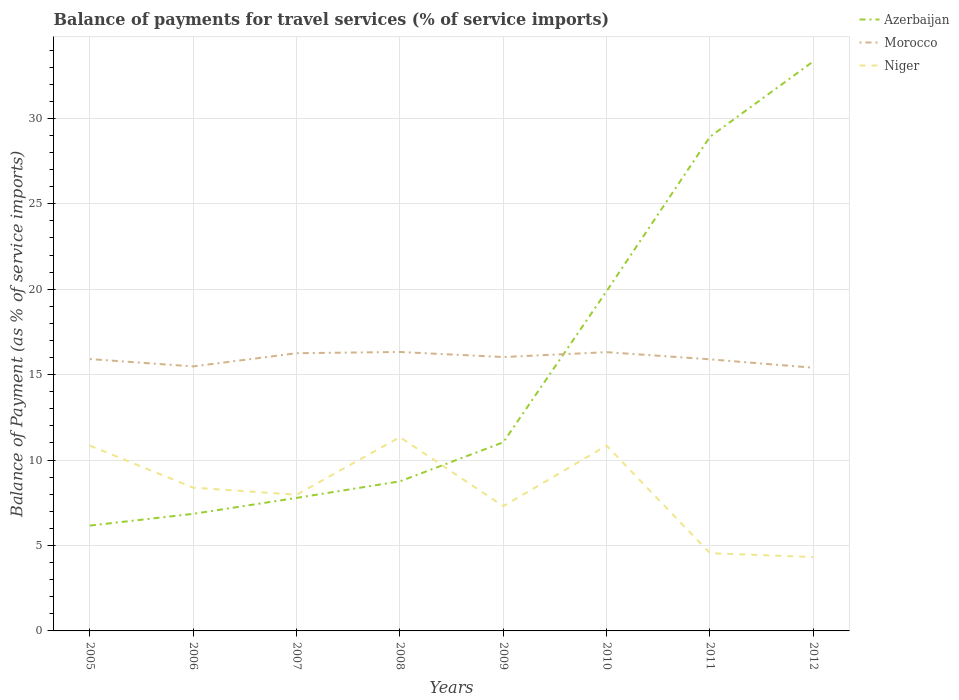How many different coloured lines are there?
Offer a very short reply. 3. Does the line corresponding to Morocco intersect with the line corresponding to Azerbaijan?
Make the answer very short. Yes. Is the number of lines equal to the number of legend labels?
Your response must be concise. Yes. Across all years, what is the maximum balance of payments for travel services in Azerbaijan?
Offer a terse response. 6.17. In which year was the balance of payments for travel services in Morocco maximum?
Your answer should be compact. 2012. What is the total balance of payments for travel services in Niger in the graph?
Offer a very short reply. 6.52. What is the difference between the highest and the second highest balance of payments for travel services in Morocco?
Make the answer very short. 0.92. How many lines are there?
Make the answer very short. 3. Are the values on the major ticks of Y-axis written in scientific E-notation?
Offer a terse response. No. Does the graph contain grids?
Ensure brevity in your answer.  Yes. Where does the legend appear in the graph?
Offer a terse response. Top right. How many legend labels are there?
Ensure brevity in your answer.  3. What is the title of the graph?
Ensure brevity in your answer.  Balance of payments for travel services (% of service imports). What is the label or title of the Y-axis?
Give a very brief answer. Balance of Payment (as % of service imports). What is the Balance of Payment (as % of service imports) in Azerbaijan in 2005?
Make the answer very short. 6.17. What is the Balance of Payment (as % of service imports) of Morocco in 2005?
Your answer should be compact. 15.91. What is the Balance of Payment (as % of service imports) of Niger in 2005?
Offer a terse response. 10.84. What is the Balance of Payment (as % of service imports) in Azerbaijan in 2006?
Ensure brevity in your answer.  6.85. What is the Balance of Payment (as % of service imports) in Morocco in 2006?
Make the answer very short. 15.48. What is the Balance of Payment (as % of service imports) of Niger in 2006?
Offer a terse response. 8.39. What is the Balance of Payment (as % of service imports) of Azerbaijan in 2007?
Your response must be concise. 7.79. What is the Balance of Payment (as % of service imports) of Morocco in 2007?
Your response must be concise. 16.25. What is the Balance of Payment (as % of service imports) of Niger in 2007?
Offer a terse response. 7.97. What is the Balance of Payment (as % of service imports) in Azerbaijan in 2008?
Ensure brevity in your answer.  8.75. What is the Balance of Payment (as % of service imports) in Morocco in 2008?
Ensure brevity in your answer.  16.33. What is the Balance of Payment (as % of service imports) in Niger in 2008?
Your answer should be very brief. 11.34. What is the Balance of Payment (as % of service imports) in Azerbaijan in 2009?
Your response must be concise. 11.04. What is the Balance of Payment (as % of service imports) in Morocco in 2009?
Offer a very short reply. 16.03. What is the Balance of Payment (as % of service imports) of Niger in 2009?
Offer a very short reply. 7.3. What is the Balance of Payment (as % of service imports) in Azerbaijan in 2010?
Offer a very short reply. 19.89. What is the Balance of Payment (as % of service imports) in Morocco in 2010?
Keep it short and to the point. 16.32. What is the Balance of Payment (as % of service imports) of Niger in 2010?
Your answer should be compact. 10.85. What is the Balance of Payment (as % of service imports) in Azerbaijan in 2011?
Your answer should be very brief. 28.92. What is the Balance of Payment (as % of service imports) in Morocco in 2011?
Your answer should be very brief. 15.9. What is the Balance of Payment (as % of service imports) in Niger in 2011?
Your answer should be very brief. 4.55. What is the Balance of Payment (as % of service imports) of Azerbaijan in 2012?
Provide a short and direct response. 33.34. What is the Balance of Payment (as % of service imports) in Morocco in 2012?
Make the answer very short. 15.41. What is the Balance of Payment (as % of service imports) in Niger in 2012?
Ensure brevity in your answer.  4.32. Across all years, what is the maximum Balance of Payment (as % of service imports) of Azerbaijan?
Offer a terse response. 33.34. Across all years, what is the maximum Balance of Payment (as % of service imports) in Morocco?
Make the answer very short. 16.33. Across all years, what is the maximum Balance of Payment (as % of service imports) of Niger?
Your answer should be very brief. 11.34. Across all years, what is the minimum Balance of Payment (as % of service imports) of Azerbaijan?
Provide a short and direct response. 6.17. Across all years, what is the minimum Balance of Payment (as % of service imports) in Morocco?
Provide a succinct answer. 15.41. Across all years, what is the minimum Balance of Payment (as % of service imports) in Niger?
Provide a succinct answer. 4.32. What is the total Balance of Payment (as % of service imports) in Azerbaijan in the graph?
Provide a short and direct response. 122.75. What is the total Balance of Payment (as % of service imports) of Morocco in the graph?
Your response must be concise. 127.63. What is the total Balance of Payment (as % of service imports) of Niger in the graph?
Provide a short and direct response. 65.56. What is the difference between the Balance of Payment (as % of service imports) in Azerbaijan in 2005 and that in 2006?
Your answer should be compact. -0.69. What is the difference between the Balance of Payment (as % of service imports) in Morocco in 2005 and that in 2006?
Offer a terse response. 0.43. What is the difference between the Balance of Payment (as % of service imports) of Niger in 2005 and that in 2006?
Your response must be concise. 2.46. What is the difference between the Balance of Payment (as % of service imports) of Azerbaijan in 2005 and that in 2007?
Offer a terse response. -1.62. What is the difference between the Balance of Payment (as % of service imports) in Morocco in 2005 and that in 2007?
Make the answer very short. -0.34. What is the difference between the Balance of Payment (as % of service imports) of Niger in 2005 and that in 2007?
Provide a succinct answer. 2.87. What is the difference between the Balance of Payment (as % of service imports) of Azerbaijan in 2005 and that in 2008?
Give a very brief answer. -2.59. What is the difference between the Balance of Payment (as % of service imports) of Morocco in 2005 and that in 2008?
Provide a short and direct response. -0.42. What is the difference between the Balance of Payment (as % of service imports) of Niger in 2005 and that in 2008?
Provide a succinct answer. -0.5. What is the difference between the Balance of Payment (as % of service imports) of Azerbaijan in 2005 and that in 2009?
Ensure brevity in your answer.  -4.87. What is the difference between the Balance of Payment (as % of service imports) in Morocco in 2005 and that in 2009?
Your answer should be very brief. -0.12. What is the difference between the Balance of Payment (as % of service imports) in Niger in 2005 and that in 2009?
Make the answer very short. 3.54. What is the difference between the Balance of Payment (as % of service imports) of Azerbaijan in 2005 and that in 2010?
Your answer should be very brief. -13.72. What is the difference between the Balance of Payment (as % of service imports) in Morocco in 2005 and that in 2010?
Provide a succinct answer. -0.41. What is the difference between the Balance of Payment (as % of service imports) of Niger in 2005 and that in 2010?
Your answer should be very brief. -0. What is the difference between the Balance of Payment (as % of service imports) of Azerbaijan in 2005 and that in 2011?
Make the answer very short. -22.76. What is the difference between the Balance of Payment (as % of service imports) in Morocco in 2005 and that in 2011?
Ensure brevity in your answer.  0.01. What is the difference between the Balance of Payment (as % of service imports) in Niger in 2005 and that in 2011?
Offer a very short reply. 6.29. What is the difference between the Balance of Payment (as % of service imports) in Azerbaijan in 2005 and that in 2012?
Make the answer very short. -27.17. What is the difference between the Balance of Payment (as % of service imports) in Morocco in 2005 and that in 2012?
Keep it short and to the point. 0.51. What is the difference between the Balance of Payment (as % of service imports) of Niger in 2005 and that in 2012?
Your answer should be very brief. 6.52. What is the difference between the Balance of Payment (as % of service imports) of Azerbaijan in 2006 and that in 2007?
Keep it short and to the point. -0.93. What is the difference between the Balance of Payment (as % of service imports) in Morocco in 2006 and that in 2007?
Provide a succinct answer. -0.77. What is the difference between the Balance of Payment (as % of service imports) of Niger in 2006 and that in 2007?
Provide a succinct answer. 0.41. What is the difference between the Balance of Payment (as % of service imports) of Azerbaijan in 2006 and that in 2008?
Offer a terse response. -1.9. What is the difference between the Balance of Payment (as % of service imports) in Morocco in 2006 and that in 2008?
Your answer should be very brief. -0.84. What is the difference between the Balance of Payment (as % of service imports) in Niger in 2006 and that in 2008?
Ensure brevity in your answer.  -2.96. What is the difference between the Balance of Payment (as % of service imports) of Azerbaijan in 2006 and that in 2009?
Offer a very short reply. -4.19. What is the difference between the Balance of Payment (as % of service imports) of Morocco in 2006 and that in 2009?
Offer a terse response. -0.55. What is the difference between the Balance of Payment (as % of service imports) of Niger in 2006 and that in 2009?
Provide a succinct answer. 1.09. What is the difference between the Balance of Payment (as % of service imports) of Azerbaijan in 2006 and that in 2010?
Make the answer very short. -13.04. What is the difference between the Balance of Payment (as % of service imports) in Morocco in 2006 and that in 2010?
Provide a short and direct response. -0.83. What is the difference between the Balance of Payment (as % of service imports) of Niger in 2006 and that in 2010?
Your answer should be compact. -2.46. What is the difference between the Balance of Payment (as % of service imports) in Azerbaijan in 2006 and that in 2011?
Offer a very short reply. -22.07. What is the difference between the Balance of Payment (as % of service imports) of Morocco in 2006 and that in 2011?
Make the answer very short. -0.41. What is the difference between the Balance of Payment (as % of service imports) of Niger in 2006 and that in 2011?
Provide a short and direct response. 3.84. What is the difference between the Balance of Payment (as % of service imports) in Azerbaijan in 2006 and that in 2012?
Provide a succinct answer. -26.49. What is the difference between the Balance of Payment (as % of service imports) of Morocco in 2006 and that in 2012?
Ensure brevity in your answer.  0.08. What is the difference between the Balance of Payment (as % of service imports) of Niger in 2006 and that in 2012?
Provide a short and direct response. 4.06. What is the difference between the Balance of Payment (as % of service imports) in Azerbaijan in 2007 and that in 2008?
Your answer should be very brief. -0.97. What is the difference between the Balance of Payment (as % of service imports) in Morocco in 2007 and that in 2008?
Offer a terse response. -0.07. What is the difference between the Balance of Payment (as % of service imports) of Niger in 2007 and that in 2008?
Your answer should be very brief. -3.37. What is the difference between the Balance of Payment (as % of service imports) of Azerbaijan in 2007 and that in 2009?
Your response must be concise. -3.26. What is the difference between the Balance of Payment (as % of service imports) of Morocco in 2007 and that in 2009?
Offer a very short reply. 0.22. What is the difference between the Balance of Payment (as % of service imports) in Niger in 2007 and that in 2009?
Give a very brief answer. 0.67. What is the difference between the Balance of Payment (as % of service imports) in Azerbaijan in 2007 and that in 2010?
Offer a terse response. -12.1. What is the difference between the Balance of Payment (as % of service imports) of Morocco in 2007 and that in 2010?
Offer a very short reply. -0.06. What is the difference between the Balance of Payment (as % of service imports) of Niger in 2007 and that in 2010?
Offer a terse response. -2.87. What is the difference between the Balance of Payment (as % of service imports) of Azerbaijan in 2007 and that in 2011?
Give a very brief answer. -21.14. What is the difference between the Balance of Payment (as % of service imports) in Morocco in 2007 and that in 2011?
Offer a terse response. 0.36. What is the difference between the Balance of Payment (as % of service imports) in Niger in 2007 and that in 2011?
Keep it short and to the point. 3.42. What is the difference between the Balance of Payment (as % of service imports) of Azerbaijan in 2007 and that in 2012?
Offer a very short reply. -25.55. What is the difference between the Balance of Payment (as % of service imports) of Morocco in 2007 and that in 2012?
Your response must be concise. 0.85. What is the difference between the Balance of Payment (as % of service imports) of Niger in 2007 and that in 2012?
Ensure brevity in your answer.  3.65. What is the difference between the Balance of Payment (as % of service imports) in Azerbaijan in 2008 and that in 2009?
Offer a very short reply. -2.29. What is the difference between the Balance of Payment (as % of service imports) in Morocco in 2008 and that in 2009?
Offer a terse response. 0.3. What is the difference between the Balance of Payment (as % of service imports) in Niger in 2008 and that in 2009?
Offer a very short reply. 4.04. What is the difference between the Balance of Payment (as % of service imports) in Azerbaijan in 2008 and that in 2010?
Make the answer very short. -11.13. What is the difference between the Balance of Payment (as % of service imports) of Morocco in 2008 and that in 2010?
Give a very brief answer. 0.01. What is the difference between the Balance of Payment (as % of service imports) of Niger in 2008 and that in 2010?
Your answer should be compact. 0.5. What is the difference between the Balance of Payment (as % of service imports) in Azerbaijan in 2008 and that in 2011?
Offer a very short reply. -20.17. What is the difference between the Balance of Payment (as % of service imports) of Morocco in 2008 and that in 2011?
Provide a short and direct response. 0.43. What is the difference between the Balance of Payment (as % of service imports) of Niger in 2008 and that in 2011?
Your answer should be very brief. 6.79. What is the difference between the Balance of Payment (as % of service imports) of Azerbaijan in 2008 and that in 2012?
Your response must be concise. -24.58. What is the difference between the Balance of Payment (as % of service imports) of Morocco in 2008 and that in 2012?
Your response must be concise. 0.92. What is the difference between the Balance of Payment (as % of service imports) of Niger in 2008 and that in 2012?
Ensure brevity in your answer.  7.02. What is the difference between the Balance of Payment (as % of service imports) in Azerbaijan in 2009 and that in 2010?
Offer a terse response. -8.85. What is the difference between the Balance of Payment (as % of service imports) in Morocco in 2009 and that in 2010?
Provide a succinct answer. -0.29. What is the difference between the Balance of Payment (as % of service imports) in Niger in 2009 and that in 2010?
Offer a terse response. -3.55. What is the difference between the Balance of Payment (as % of service imports) of Azerbaijan in 2009 and that in 2011?
Provide a short and direct response. -17.88. What is the difference between the Balance of Payment (as % of service imports) of Morocco in 2009 and that in 2011?
Provide a short and direct response. 0.13. What is the difference between the Balance of Payment (as % of service imports) of Niger in 2009 and that in 2011?
Make the answer very short. 2.75. What is the difference between the Balance of Payment (as % of service imports) of Azerbaijan in 2009 and that in 2012?
Offer a terse response. -22.3. What is the difference between the Balance of Payment (as % of service imports) in Morocco in 2009 and that in 2012?
Ensure brevity in your answer.  0.62. What is the difference between the Balance of Payment (as % of service imports) of Niger in 2009 and that in 2012?
Offer a terse response. 2.98. What is the difference between the Balance of Payment (as % of service imports) in Azerbaijan in 2010 and that in 2011?
Give a very brief answer. -9.04. What is the difference between the Balance of Payment (as % of service imports) of Morocco in 2010 and that in 2011?
Provide a short and direct response. 0.42. What is the difference between the Balance of Payment (as % of service imports) in Niger in 2010 and that in 2011?
Your response must be concise. 6.29. What is the difference between the Balance of Payment (as % of service imports) of Azerbaijan in 2010 and that in 2012?
Make the answer very short. -13.45. What is the difference between the Balance of Payment (as % of service imports) of Morocco in 2010 and that in 2012?
Ensure brevity in your answer.  0.91. What is the difference between the Balance of Payment (as % of service imports) of Niger in 2010 and that in 2012?
Your answer should be compact. 6.52. What is the difference between the Balance of Payment (as % of service imports) of Azerbaijan in 2011 and that in 2012?
Make the answer very short. -4.41. What is the difference between the Balance of Payment (as % of service imports) of Morocco in 2011 and that in 2012?
Your answer should be compact. 0.49. What is the difference between the Balance of Payment (as % of service imports) of Niger in 2011 and that in 2012?
Make the answer very short. 0.23. What is the difference between the Balance of Payment (as % of service imports) in Azerbaijan in 2005 and the Balance of Payment (as % of service imports) in Morocco in 2006?
Ensure brevity in your answer.  -9.32. What is the difference between the Balance of Payment (as % of service imports) of Azerbaijan in 2005 and the Balance of Payment (as % of service imports) of Niger in 2006?
Make the answer very short. -2.22. What is the difference between the Balance of Payment (as % of service imports) in Morocco in 2005 and the Balance of Payment (as % of service imports) in Niger in 2006?
Make the answer very short. 7.53. What is the difference between the Balance of Payment (as % of service imports) of Azerbaijan in 2005 and the Balance of Payment (as % of service imports) of Morocco in 2007?
Provide a succinct answer. -10.09. What is the difference between the Balance of Payment (as % of service imports) in Azerbaijan in 2005 and the Balance of Payment (as % of service imports) in Niger in 2007?
Keep it short and to the point. -1.81. What is the difference between the Balance of Payment (as % of service imports) of Morocco in 2005 and the Balance of Payment (as % of service imports) of Niger in 2007?
Offer a terse response. 7.94. What is the difference between the Balance of Payment (as % of service imports) in Azerbaijan in 2005 and the Balance of Payment (as % of service imports) in Morocco in 2008?
Keep it short and to the point. -10.16. What is the difference between the Balance of Payment (as % of service imports) of Azerbaijan in 2005 and the Balance of Payment (as % of service imports) of Niger in 2008?
Offer a terse response. -5.17. What is the difference between the Balance of Payment (as % of service imports) in Morocco in 2005 and the Balance of Payment (as % of service imports) in Niger in 2008?
Offer a very short reply. 4.57. What is the difference between the Balance of Payment (as % of service imports) of Azerbaijan in 2005 and the Balance of Payment (as % of service imports) of Morocco in 2009?
Keep it short and to the point. -9.86. What is the difference between the Balance of Payment (as % of service imports) in Azerbaijan in 2005 and the Balance of Payment (as % of service imports) in Niger in 2009?
Offer a terse response. -1.13. What is the difference between the Balance of Payment (as % of service imports) in Morocco in 2005 and the Balance of Payment (as % of service imports) in Niger in 2009?
Offer a very short reply. 8.61. What is the difference between the Balance of Payment (as % of service imports) in Azerbaijan in 2005 and the Balance of Payment (as % of service imports) in Morocco in 2010?
Offer a terse response. -10.15. What is the difference between the Balance of Payment (as % of service imports) in Azerbaijan in 2005 and the Balance of Payment (as % of service imports) in Niger in 2010?
Provide a short and direct response. -4.68. What is the difference between the Balance of Payment (as % of service imports) of Morocco in 2005 and the Balance of Payment (as % of service imports) of Niger in 2010?
Offer a terse response. 5.07. What is the difference between the Balance of Payment (as % of service imports) in Azerbaijan in 2005 and the Balance of Payment (as % of service imports) in Morocco in 2011?
Give a very brief answer. -9.73. What is the difference between the Balance of Payment (as % of service imports) of Azerbaijan in 2005 and the Balance of Payment (as % of service imports) of Niger in 2011?
Offer a terse response. 1.62. What is the difference between the Balance of Payment (as % of service imports) of Morocco in 2005 and the Balance of Payment (as % of service imports) of Niger in 2011?
Give a very brief answer. 11.36. What is the difference between the Balance of Payment (as % of service imports) of Azerbaijan in 2005 and the Balance of Payment (as % of service imports) of Morocco in 2012?
Provide a short and direct response. -9.24. What is the difference between the Balance of Payment (as % of service imports) of Azerbaijan in 2005 and the Balance of Payment (as % of service imports) of Niger in 2012?
Ensure brevity in your answer.  1.85. What is the difference between the Balance of Payment (as % of service imports) of Morocco in 2005 and the Balance of Payment (as % of service imports) of Niger in 2012?
Provide a short and direct response. 11.59. What is the difference between the Balance of Payment (as % of service imports) of Azerbaijan in 2006 and the Balance of Payment (as % of service imports) of Morocco in 2007?
Give a very brief answer. -9.4. What is the difference between the Balance of Payment (as % of service imports) of Azerbaijan in 2006 and the Balance of Payment (as % of service imports) of Niger in 2007?
Offer a very short reply. -1.12. What is the difference between the Balance of Payment (as % of service imports) of Morocco in 2006 and the Balance of Payment (as % of service imports) of Niger in 2007?
Make the answer very short. 7.51. What is the difference between the Balance of Payment (as % of service imports) in Azerbaijan in 2006 and the Balance of Payment (as % of service imports) in Morocco in 2008?
Your response must be concise. -9.48. What is the difference between the Balance of Payment (as % of service imports) of Azerbaijan in 2006 and the Balance of Payment (as % of service imports) of Niger in 2008?
Offer a very short reply. -4.49. What is the difference between the Balance of Payment (as % of service imports) in Morocco in 2006 and the Balance of Payment (as % of service imports) in Niger in 2008?
Provide a short and direct response. 4.14. What is the difference between the Balance of Payment (as % of service imports) of Azerbaijan in 2006 and the Balance of Payment (as % of service imports) of Morocco in 2009?
Offer a terse response. -9.18. What is the difference between the Balance of Payment (as % of service imports) of Azerbaijan in 2006 and the Balance of Payment (as % of service imports) of Niger in 2009?
Offer a very short reply. -0.45. What is the difference between the Balance of Payment (as % of service imports) of Morocco in 2006 and the Balance of Payment (as % of service imports) of Niger in 2009?
Your answer should be very brief. 8.18. What is the difference between the Balance of Payment (as % of service imports) in Azerbaijan in 2006 and the Balance of Payment (as % of service imports) in Morocco in 2010?
Provide a short and direct response. -9.47. What is the difference between the Balance of Payment (as % of service imports) in Azerbaijan in 2006 and the Balance of Payment (as % of service imports) in Niger in 2010?
Offer a very short reply. -3.99. What is the difference between the Balance of Payment (as % of service imports) in Morocco in 2006 and the Balance of Payment (as % of service imports) in Niger in 2010?
Ensure brevity in your answer.  4.64. What is the difference between the Balance of Payment (as % of service imports) of Azerbaijan in 2006 and the Balance of Payment (as % of service imports) of Morocco in 2011?
Keep it short and to the point. -9.04. What is the difference between the Balance of Payment (as % of service imports) in Azerbaijan in 2006 and the Balance of Payment (as % of service imports) in Niger in 2011?
Offer a very short reply. 2.3. What is the difference between the Balance of Payment (as % of service imports) in Morocco in 2006 and the Balance of Payment (as % of service imports) in Niger in 2011?
Keep it short and to the point. 10.93. What is the difference between the Balance of Payment (as % of service imports) of Azerbaijan in 2006 and the Balance of Payment (as % of service imports) of Morocco in 2012?
Your response must be concise. -8.55. What is the difference between the Balance of Payment (as % of service imports) in Azerbaijan in 2006 and the Balance of Payment (as % of service imports) in Niger in 2012?
Make the answer very short. 2.53. What is the difference between the Balance of Payment (as % of service imports) in Morocco in 2006 and the Balance of Payment (as % of service imports) in Niger in 2012?
Your answer should be compact. 11.16. What is the difference between the Balance of Payment (as % of service imports) of Azerbaijan in 2007 and the Balance of Payment (as % of service imports) of Morocco in 2008?
Make the answer very short. -8.54. What is the difference between the Balance of Payment (as % of service imports) in Azerbaijan in 2007 and the Balance of Payment (as % of service imports) in Niger in 2008?
Provide a short and direct response. -3.56. What is the difference between the Balance of Payment (as % of service imports) in Morocco in 2007 and the Balance of Payment (as % of service imports) in Niger in 2008?
Provide a short and direct response. 4.91. What is the difference between the Balance of Payment (as % of service imports) in Azerbaijan in 2007 and the Balance of Payment (as % of service imports) in Morocco in 2009?
Ensure brevity in your answer.  -8.24. What is the difference between the Balance of Payment (as % of service imports) in Azerbaijan in 2007 and the Balance of Payment (as % of service imports) in Niger in 2009?
Offer a terse response. 0.49. What is the difference between the Balance of Payment (as % of service imports) of Morocco in 2007 and the Balance of Payment (as % of service imports) of Niger in 2009?
Your answer should be compact. 8.95. What is the difference between the Balance of Payment (as % of service imports) of Azerbaijan in 2007 and the Balance of Payment (as % of service imports) of Morocco in 2010?
Give a very brief answer. -8.53. What is the difference between the Balance of Payment (as % of service imports) of Azerbaijan in 2007 and the Balance of Payment (as % of service imports) of Niger in 2010?
Keep it short and to the point. -3.06. What is the difference between the Balance of Payment (as % of service imports) of Morocco in 2007 and the Balance of Payment (as % of service imports) of Niger in 2010?
Make the answer very short. 5.41. What is the difference between the Balance of Payment (as % of service imports) of Azerbaijan in 2007 and the Balance of Payment (as % of service imports) of Morocco in 2011?
Provide a short and direct response. -8.11. What is the difference between the Balance of Payment (as % of service imports) in Azerbaijan in 2007 and the Balance of Payment (as % of service imports) in Niger in 2011?
Keep it short and to the point. 3.23. What is the difference between the Balance of Payment (as % of service imports) in Morocco in 2007 and the Balance of Payment (as % of service imports) in Niger in 2011?
Your answer should be very brief. 11.7. What is the difference between the Balance of Payment (as % of service imports) in Azerbaijan in 2007 and the Balance of Payment (as % of service imports) in Morocco in 2012?
Provide a short and direct response. -7.62. What is the difference between the Balance of Payment (as % of service imports) of Azerbaijan in 2007 and the Balance of Payment (as % of service imports) of Niger in 2012?
Offer a very short reply. 3.46. What is the difference between the Balance of Payment (as % of service imports) of Morocco in 2007 and the Balance of Payment (as % of service imports) of Niger in 2012?
Provide a short and direct response. 11.93. What is the difference between the Balance of Payment (as % of service imports) of Azerbaijan in 2008 and the Balance of Payment (as % of service imports) of Morocco in 2009?
Your response must be concise. -7.28. What is the difference between the Balance of Payment (as % of service imports) of Azerbaijan in 2008 and the Balance of Payment (as % of service imports) of Niger in 2009?
Provide a short and direct response. 1.45. What is the difference between the Balance of Payment (as % of service imports) in Morocco in 2008 and the Balance of Payment (as % of service imports) in Niger in 2009?
Provide a succinct answer. 9.03. What is the difference between the Balance of Payment (as % of service imports) in Azerbaijan in 2008 and the Balance of Payment (as % of service imports) in Morocco in 2010?
Your answer should be very brief. -7.56. What is the difference between the Balance of Payment (as % of service imports) in Azerbaijan in 2008 and the Balance of Payment (as % of service imports) in Niger in 2010?
Ensure brevity in your answer.  -2.09. What is the difference between the Balance of Payment (as % of service imports) in Morocco in 2008 and the Balance of Payment (as % of service imports) in Niger in 2010?
Provide a succinct answer. 5.48. What is the difference between the Balance of Payment (as % of service imports) of Azerbaijan in 2008 and the Balance of Payment (as % of service imports) of Morocco in 2011?
Provide a succinct answer. -7.14. What is the difference between the Balance of Payment (as % of service imports) of Azerbaijan in 2008 and the Balance of Payment (as % of service imports) of Niger in 2011?
Make the answer very short. 4.2. What is the difference between the Balance of Payment (as % of service imports) of Morocco in 2008 and the Balance of Payment (as % of service imports) of Niger in 2011?
Give a very brief answer. 11.78. What is the difference between the Balance of Payment (as % of service imports) of Azerbaijan in 2008 and the Balance of Payment (as % of service imports) of Morocco in 2012?
Your answer should be very brief. -6.65. What is the difference between the Balance of Payment (as % of service imports) in Azerbaijan in 2008 and the Balance of Payment (as % of service imports) in Niger in 2012?
Your answer should be very brief. 4.43. What is the difference between the Balance of Payment (as % of service imports) of Morocco in 2008 and the Balance of Payment (as % of service imports) of Niger in 2012?
Provide a short and direct response. 12.01. What is the difference between the Balance of Payment (as % of service imports) of Azerbaijan in 2009 and the Balance of Payment (as % of service imports) of Morocco in 2010?
Your answer should be compact. -5.28. What is the difference between the Balance of Payment (as % of service imports) of Azerbaijan in 2009 and the Balance of Payment (as % of service imports) of Niger in 2010?
Your answer should be very brief. 0.2. What is the difference between the Balance of Payment (as % of service imports) in Morocco in 2009 and the Balance of Payment (as % of service imports) in Niger in 2010?
Ensure brevity in your answer.  5.18. What is the difference between the Balance of Payment (as % of service imports) of Azerbaijan in 2009 and the Balance of Payment (as % of service imports) of Morocco in 2011?
Provide a short and direct response. -4.86. What is the difference between the Balance of Payment (as % of service imports) of Azerbaijan in 2009 and the Balance of Payment (as % of service imports) of Niger in 2011?
Your response must be concise. 6.49. What is the difference between the Balance of Payment (as % of service imports) of Morocco in 2009 and the Balance of Payment (as % of service imports) of Niger in 2011?
Your answer should be compact. 11.48. What is the difference between the Balance of Payment (as % of service imports) in Azerbaijan in 2009 and the Balance of Payment (as % of service imports) in Morocco in 2012?
Your answer should be very brief. -4.36. What is the difference between the Balance of Payment (as % of service imports) of Azerbaijan in 2009 and the Balance of Payment (as % of service imports) of Niger in 2012?
Ensure brevity in your answer.  6.72. What is the difference between the Balance of Payment (as % of service imports) of Morocco in 2009 and the Balance of Payment (as % of service imports) of Niger in 2012?
Your response must be concise. 11.71. What is the difference between the Balance of Payment (as % of service imports) in Azerbaijan in 2010 and the Balance of Payment (as % of service imports) in Morocco in 2011?
Your answer should be compact. 3.99. What is the difference between the Balance of Payment (as % of service imports) in Azerbaijan in 2010 and the Balance of Payment (as % of service imports) in Niger in 2011?
Your answer should be very brief. 15.34. What is the difference between the Balance of Payment (as % of service imports) in Morocco in 2010 and the Balance of Payment (as % of service imports) in Niger in 2011?
Provide a short and direct response. 11.77. What is the difference between the Balance of Payment (as % of service imports) of Azerbaijan in 2010 and the Balance of Payment (as % of service imports) of Morocco in 2012?
Offer a very short reply. 4.48. What is the difference between the Balance of Payment (as % of service imports) of Azerbaijan in 2010 and the Balance of Payment (as % of service imports) of Niger in 2012?
Your answer should be very brief. 15.57. What is the difference between the Balance of Payment (as % of service imports) in Morocco in 2010 and the Balance of Payment (as % of service imports) in Niger in 2012?
Offer a terse response. 12. What is the difference between the Balance of Payment (as % of service imports) of Azerbaijan in 2011 and the Balance of Payment (as % of service imports) of Morocco in 2012?
Make the answer very short. 13.52. What is the difference between the Balance of Payment (as % of service imports) in Azerbaijan in 2011 and the Balance of Payment (as % of service imports) in Niger in 2012?
Your response must be concise. 24.6. What is the difference between the Balance of Payment (as % of service imports) of Morocco in 2011 and the Balance of Payment (as % of service imports) of Niger in 2012?
Your answer should be compact. 11.58. What is the average Balance of Payment (as % of service imports) of Azerbaijan per year?
Keep it short and to the point. 15.34. What is the average Balance of Payment (as % of service imports) of Morocco per year?
Keep it short and to the point. 15.95. What is the average Balance of Payment (as % of service imports) of Niger per year?
Your answer should be very brief. 8.2. In the year 2005, what is the difference between the Balance of Payment (as % of service imports) in Azerbaijan and Balance of Payment (as % of service imports) in Morocco?
Give a very brief answer. -9.74. In the year 2005, what is the difference between the Balance of Payment (as % of service imports) in Azerbaijan and Balance of Payment (as % of service imports) in Niger?
Keep it short and to the point. -4.68. In the year 2005, what is the difference between the Balance of Payment (as % of service imports) of Morocco and Balance of Payment (as % of service imports) of Niger?
Your answer should be very brief. 5.07. In the year 2006, what is the difference between the Balance of Payment (as % of service imports) in Azerbaijan and Balance of Payment (as % of service imports) in Morocco?
Ensure brevity in your answer.  -8.63. In the year 2006, what is the difference between the Balance of Payment (as % of service imports) of Azerbaijan and Balance of Payment (as % of service imports) of Niger?
Offer a terse response. -1.53. In the year 2006, what is the difference between the Balance of Payment (as % of service imports) of Morocco and Balance of Payment (as % of service imports) of Niger?
Ensure brevity in your answer.  7.1. In the year 2007, what is the difference between the Balance of Payment (as % of service imports) in Azerbaijan and Balance of Payment (as % of service imports) in Morocco?
Your answer should be very brief. -8.47. In the year 2007, what is the difference between the Balance of Payment (as % of service imports) in Azerbaijan and Balance of Payment (as % of service imports) in Niger?
Provide a succinct answer. -0.19. In the year 2007, what is the difference between the Balance of Payment (as % of service imports) in Morocco and Balance of Payment (as % of service imports) in Niger?
Ensure brevity in your answer.  8.28. In the year 2008, what is the difference between the Balance of Payment (as % of service imports) in Azerbaijan and Balance of Payment (as % of service imports) in Morocco?
Offer a very short reply. -7.57. In the year 2008, what is the difference between the Balance of Payment (as % of service imports) in Azerbaijan and Balance of Payment (as % of service imports) in Niger?
Your answer should be very brief. -2.59. In the year 2008, what is the difference between the Balance of Payment (as % of service imports) of Morocco and Balance of Payment (as % of service imports) of Niger?
Make the answer very short. 4.99. In the year 2009, what is the difference between the Balance of Payment (as % of service imports) in Azerbaijan and Balance of Payment (as % of service imports) in Morocco?
Your answer should be compact. -4.99. In the year 2009, what is the difference between the Balance of Payment (as % of service imports) in Azerbaijan and Balance of Payment (as % of service imports) in Niger?
Your answer should be very brief. 3.74. In the year 2009, what is the difference between the Balance of Payment (as % of service imports) in Morocco and Balance of Payment (as % of service imports) in Niger?
Provide a short and direct response. 8.73. In the year 2010, what is the difference between the Balance of Payment (as % of service imports) of Azerbaijan and Balance of Payment (as % of service imports) of Morocco?
Give a very brief answer. 3.57. In the year 2010, what is the difference between the Balance of Payment (as % of service imports) in Azerbaijan and Balance of Payment (as % of service imports) in Niger?
Your answer should be very brief. 9.04. In the year 2010, what is the difference between the Balance of Payment (as % of service imports) of Morocco and Balance of Payment (as % of service imports) of Niger?
Your response must be concise. 5.47. In the year 2011, what is the difference between the Balance of Payment (as % of service imports) of Azerbaijan and Balance of Payment (as % of service imports) of Morocco?
Offer a terse response. 13.03. In the year 2011, what is the difference between the Balance of Payment (as % of service imports) of Azerbaijan and Balance of Payment (as % of service imports) of Niger?
Provide a succinct answer. 24.37. In the year 2011, what is the difference between the Balance of Payment (as % of service imports) of Morocco and Balance of Payment (as % of service imports) of Niger?
Offer a very short reply. 11.35. In the year 2012, what is the difference between the Balance of Payment (as % of service imports) of Azerbaijan and Balance of Payment (as % of service imports) of Morocco?
Your answer should be very brief. 17.93. In the year 2012, what is the difference between the Balance of Payment (as % of service imports) in Azerbaijan and Balance of Payment (as % of service imports) in Niger?
Your answer should be compact. 29.02. In the year 2012, what is the difference between the Balance of Payment (as % of service imports) in Morocco and Balance of Payment (as % of service imports) in Niger?
Provide a succinct answer. 11.08. What is the ratio of the Balance of Payment (as % of service imports) in Morocco in 2005 to that in 2006?
Give a very brief answer. 1.03. What is the ratio of the Balance of Payment (as % of service imports) of Niger in 2005 to that in 2006?
Keep it short and to the point. 1.29. What is the ratio of the Balance of Payment (as % of service imports) of Azerbaijan in 2005 to that in 2007?
Make the answer very short. 0.79. What is the ratio of the Balance of Payment (as % of service imports) in Morocco in 2005 to that in 2007?
Your answer should be compact. 0.98. What is the ratio of the Balance of Payment (as % of service imports) of Niger in 2005 to that in 2007?
Make the answer very short. 1.36. What is the ratio of the Balance of Payment (as % of service imports) in Azerbaijan in 2005 to that in 2008?
Offer a terse response. 0.7. What is the ratio of the Balance of Payment (as % of service imports) in Morocco in 2005 to that in 2008?
Offer a very short reply. 0.97. What is the ratio of the Balance of Payment (as % of service imports) in Niger in 2005 to that in 2008?
Keep it short and to the point. 0.96. What is the ratio of the Balance of Payment (as % of service imports) of Azerbaijan in 2005 to that in 2009?
Make the answer very short. 0.56. What is the ratio of the Balance of Payment (as % of service imports) of Niger in 2005 to that in 2009?
Provide a short and direct response. 1.49. What is the ratio of the Balance of Payment (as % of service imports) of Azerbaijan in 2005 to that in 2010?
Make the answer very short. 0.31. What is the ratio of the Balance of Payment (as % of service imports) in Morocco in 2005 to that in 2010?
Provide a succinct answer. 0.98. What is the ratio of the Balance of Payment (as % of service imports) in Azerbaijan in 2005 to that in 2011?
Make the answer very short. 0.21. What is the ratio of the Balance of Payment (as % of service imports) of Niger in 2005 to that in 2011?
Your answer should be very brief. 2.38. What is the ratio of the Balance of Payment (as % of service imports) in Azerbaijan in 2005 to that in 2012?
Ensure brevity in your answer.  0.18. What is the ratio of the Balance of Payment (as % of service imports) of Morocco in 2005 to that in 2012?
Offer a very short reply. 1.03. What is the ratio of the Balance of Payment (as % of service imports) in Niger in 2005 to that in 2012?
Provide a short and direct response. 2.51. What is the ratio of the Balance of Payment (as % of service imports) in Azerbaijan in 2006 to that in 2007?
Offer a terse response. 0.88. What is the ratio of the Balance of Payment (as % of service imports) in Morocco in 2006 to that in 2007?
Offer a very short reply. 0.95. What is the ratio of the Balance of Payment (as % of service imports) of Niger in 2006 to that in 2007?
Your response must be concise. 1.05. What is the ratio of the Balance of Payment (as % of service imports) of Azerbaijan in 2006 to that in 2008?
Your answer should be compact. 0.78. What is the ratio of the Balance of Payment (as % of service imports) of Morocco in 2006 to that in 2008?
Provide a short and direct response. 0.95. What is the ratio of the Balance of Payment (as % of service imports) in Niger in 2006 to that in 2008?
Offer a very short reply. 0.74. What is the ratio of the Balance of Payment (as % of service imports) in Azerbaijan in 2006 to that in 2009?
Give a very brief answer. 0.62. What is the ratio of the Balance of Payment (as % of service imports) in Morocco in 2006 to that in 2009?
Offer a terse response. 0.97. What is the ratio of the Balance of Payment (as % of service imports) of Niger in 2006 to that in 2009?
Ensure brevity in your answer.  1.15. What is the ratio of the Balance of Payment (as % of service imports) of Azerbaijan in 2006 to that in 2010?
Keep it short and to the point. 0.34. What is the ratio of the Balance of Payment (as % of service imports) in Morocco in 2006 to that in 2010?
Ensure brevity in your answer.  0.95. What is the ratio of the Balance of Payment (as % of service imports) in Niger in 2006 to that in 2010?
Give a very brief answer. 0.77. What is the ratio of the Balance of Payment (as % of service imports) in Azerbaijan in 2006 to that in 2011?
Ensure brevity in your answer.  0.24. What is the ratio of the Balance of Payment (as % of service imports) of Morocco in 2006 to that in 2011?
Ensure brevity in your answer.  0.97. What is the ratio of the Balance of Payment (as % of service imports) in Niger in 2006 to that in 2011?
Your answer should be compact. 1.84. What is the ratio of the Balance of Payment (as % of service imports) of Azerbaijan in 2006 to that in 2012?
Offer a very short reply. 0.21. What is the ratio of the Balance of Payment (as % of service imports) of Morocco in 2006 to that in 2012?
Your response must be concise. 1. What is the ratio of the Balance of Payment (as % of service imports) of Niger in 2006 to that in 2012?
Provide a succinct answer. 1.94. What is the ratio of the Balance of Payment (as % of service imports) of Azerbaijan in 2007 to that in 2008?
Ensure brevity in your answer.  0.89. What is the ratio of the Balance of Payment (as % of service imports) of Morocco in 2007 to that in 2008?
Offer a very short reply. 1. What is the ratio of the Balance of Payment (as % of service imports) of Niger in 2007 to that in 2008?
Offer a very short reply. 0.7. What is the ratio of the Balance of Payment (as % of service imports) of Azerbaijan in 2007 to that in 2009?
Ensure brevity in your answer.  0.71. What is the ratio of the Balance of Payment (as % of service imports) of Morocco in 2007 to that in 2009?
Give a very brief answer. 1.01. What is the ratio of the Balance of Payment (as % of service imports) of Niger in 2007 to that in 2009?
Your response must be concise. 1.09. What is the ratio of the Balance of Payment (as % of service imports) of Azerbaijan in 2007 to that in 2010?
Make the answer very short. 0.39. What is the ratio of the Balance of Payment (as % of service imports) of Niger in 2007 to that in 2010?
Give a very brief answer. 0.73. What is the ratio of the Balance of Payment (as % of service imports) of Azerbaijan in 2007 to that in 2011?
Ensure brevity in your answer.  0.27. What is the ratio of the Balance of Payment (as % of service imports) of Morocco in 2007 to that in 2011?
Offer a terse response. 1.02. What is the ratio of the Balance of Payment (as % of service imports) in Niger in 2007 to that in 2011?
Provide a short and direct response. 1.75. What is the ratio of the Balance of Payment (as % of service imports) in Azerbaijan in 2007 to that in 2012?
Your answer should be very brief. 0.23. What is the ratio of the Balance of Payment (as % of service imports) in Morocco in 2007 to that in 2012?
Your answer should be very brief. 1.06. What is the ratio of the Balance of Payment (as % of service imports) of Niger in 2007 to that in 2012?
Provide a short and direct response. 1.84. What is the ratio of the Balance of Payment (as % of service imports) of Azerbaijan in 2008 to that in 2009?
Provide a succinct answer. 0.79. What is the ratio of the Balance of Payment (as % of service imports) of Morocco in 2008 to that in 2009?
Give a very brief answer. 1.02. What is the ratio of the Balance of Payment (as % of service imports) in Niger in 2008 to that in 2009?
Give a very brief answer. 1.55. What is the ratio of the Balance of Payment (as % of service imports) in Azerbaijan in 2008 to that in 2010?
Offer a terse response. 0.44. What is the ratio of the Balance of Payment (as % of service imports) in Morocco in 2008 to that in 2010?
Ensure brevity in your answer.  1. What is the ratio of the Balance of Payment (as % of service imports) of Niger in 2008 to that in 2010?
Give a very brief answer. 1.05. What is the ratio of the Balance of Payment (as % of service imports) in Azerbaijan in 2008 to that in 2011?
Ensure brevity in your answer.  0.3. What is the ratio of the Balance of Payment (as % of service imports) of Morocco in 2008 to that in 2011?
Keep it short and to the point. 1.03. What is the ratio of the Balance of Payment (as % of service imports) of Niger in 2008 to that in 2011?
Give a very brief answer. 2.49. What is the ratio of the Balance of Payment (as % of service imports) of Azerbaijan in 2008 to that in 2012?
Offer a terse response. 0.26. What is the ratio of the Balance of Payment (as % of service imports) in Morocco in 2008 to that in 2012?
Keep it short and to the point. 1.06. What is the ratio of the Balance of Payment (as % of service imports) of Niger in 2008 to that in 2012?
Your response must be concise. 2.62. What is the ratio of the Balance of Payment (as % of service imports) of Azerbaijan in 2009 to that in 2010?
Ensure brevity in your answer.  0.56. What is the ratio of the Balance of Payment (as % of service imports) of Morocco in 2009 to that in 2010?
Keep it short and to the point. 0.98. What is the ratio of the Balance of Payment (as % of service imports) in Niger in 2009 to that in 2010?
Your response must be concise. 0.67. What is the ratio of the Balance of Payment (as % of service imports) of Azerbaijan in 2009 to that in 2011?
Ensure brevity in your answer.  0.38. What is the ratio of the Balance of Payment (as % of service imports) in Morocco in 2009 to that in 2011?
Make the answer very short. 1.01. What is the ratio of the Balance of Payment (as % of service imports) in Niger in 2009 to that in 2011?
Keep it short and to the point. 1.6. What is the ratio of the Balance of Payment (as % of service imports) of Azerbaijan in 2009 to that in 2012?
Offer a terse response. 0.33. What is the ratio of the Balance of Payment (as % of service imports) of Morocco in 2009 to that in 2012?
Make the answer very short. 1.04. What is the ratio of the Balance of Payment (as % of service imports) of Niger in 2009 to that in 2012?
Your answer should be compact. 1.69. What is the ratio of the Balance of Payment (as % of service imports) of Azerbaijan in 2010 to that in 2011?
Offer a terse response. 0.69. What is the ratio of the Balance of Payment (as % of service imports) in Morocco in 2010 to that in 2011?
Ensure brevity in your answer.  1.03. What is the ratio of the Balance of Payment (as % of service imports) of Niger in 2010 to that in 2011?
Your response must be concise. 2.38. What is the ratio of the Balance of Payment (as % of service imports) in Azerbaijan in 2010 to that in 2012?
Your response must be concise. 0.6. What is the ratio of the Balance of Payment (as % of service imports) in Morocco in 2010 to that in 2012?
Ensure brevity in your answer.  1.06. What is the ratio of the Balance of Payment (as % of service imports) in Niger in 2010 to that in 2012?
Give a very brief answer. 2.51. What is the ratio of the Balance of Payment (as % of service imports) of Azerbaijan in 2011 to that in 2012?
Your answer should be very brief. 0.87. What is the ratio of the Balance of Payment (as % of service imports) in Morocco in 2011 to that in 2012?
Give a very brief answer. 1.03. What is the ratio of the Balance of Payment (as % of service imports) in Niger in 2011 to that in 2012?
Offer a terse response. 1.05. What is the difference between the highest and the second highest Balance of Payment (as % of service imports) in Azerbaijan?
Provide a succinct answer. 4.41. What is the difference between the highest and the second highest Balance of Payment (as % of service imports) in Morocco?
Your response must be concise. 0.01. What is the difference between the highest and the second highest Balance of Payment (as % of service imports) in Niger?
Give a very brief answer. 0.5. What is the difference between the highest and the lowest Balance of Payment (as % of service imports) in Azerbaijan?
Offer a terse response. 27.17. What is the difference between the highest and the lowest Balance of Payment (as % of service imports) of Morocco?
Provide a succinct answer. 0.92. What is the difference between the highest and the lowest Balance of Payment (as % of service imports) in Niger?
Ensure brevity in your answer.  7.02. 